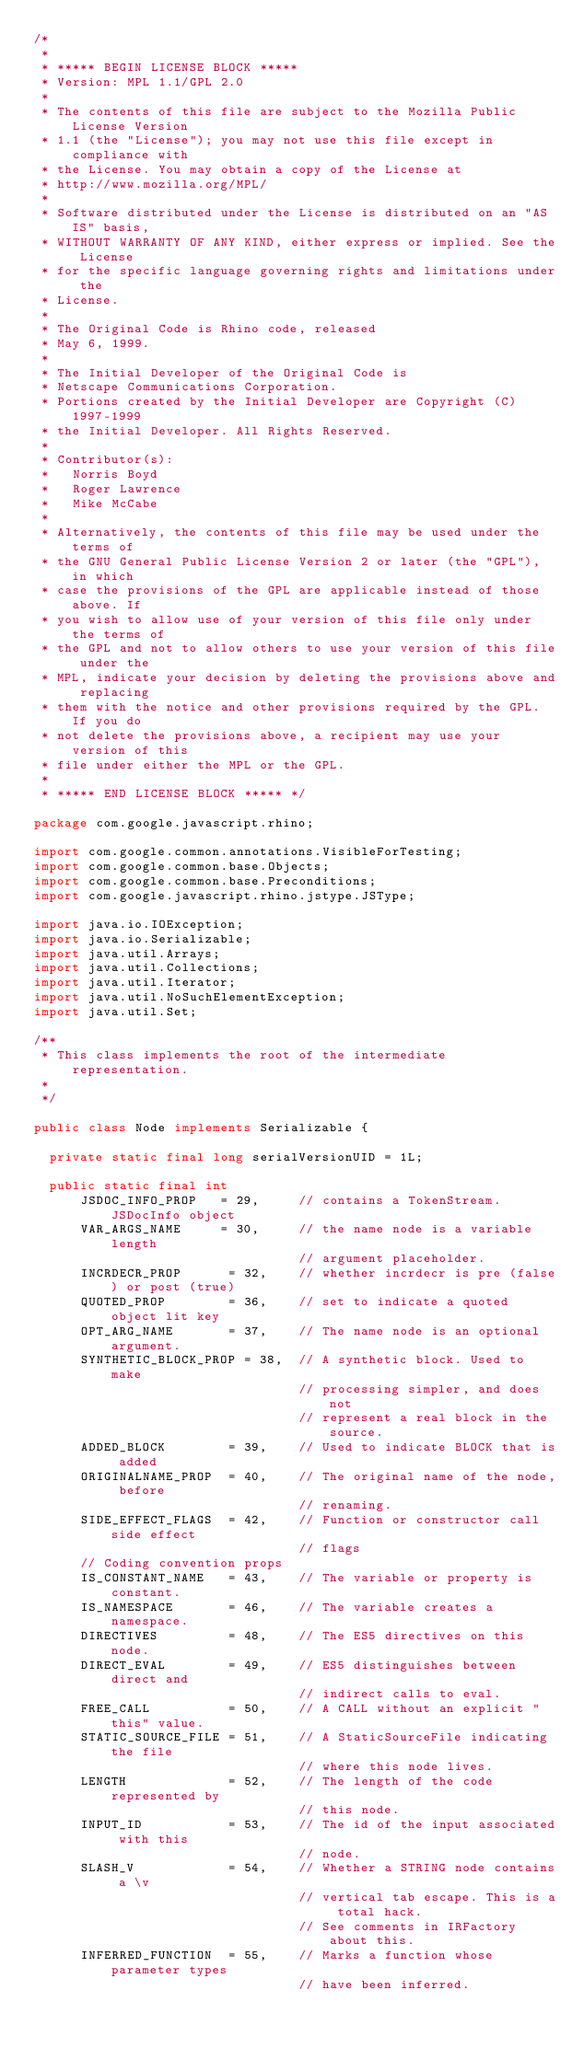<code> <loc_0><loc_0><loc_500><loc_500><_Java_>/*
 *
 * ***** BEGIN LICENSE BLOCK *****
 * Version: MPL 1.1/GPL 2.0
 *
 * The contents of this file are subject to the Mozilla Public License Version
 * 1.1 (the "License"); you may not use this file except in compliance with
 * the License. You may obtain a copy of the License at
 * http://www.mozilla.org/MPL/
 *
 * Software distributed under the License is distributed on an "AS IS" basis,
 * WITHOUT WARRANTY OF ANY KIND, either express or implied. See the License
 * for the specific language governing rights and limitations under the
 * License.
 *
 * The Original Code is Rhino code, released
 * May 6, 1999.
 *
 * The Initial Developer of the Original Code is
 * Netscape Communications Corporation.
 * Portions created by the Initial Developer are Copyright (C) 1997-1999
 * the Initial Developer. All Rights Reserved.
 *
 * Contributor(s):
 *   Norris Boyd
 *   Roger Lawrence
 *   Mike McCabe
 *
 * Alternatively, the contents of this file may be used under the terms of
 * the GNU General Public License Version 2 or later (the "GPL"), in which
 * case the provisions of the GPL are applicable instead of those above. If
 * you wish to allow use of your version of this file only under the terms of
 * the GPL and not to allow others to use your version of this file under the
 * MPL, indicate your decision by deleting the provisions above and replacing
 * them with the notice and other provisions required by the GPL. If you do
 * not delete the provisions above, a recipient may use your version of this
 * file under either the MPL or the GPL.
 *
 * ***** END LICENSE BLOCK ***** */

package com.google.javascript.rhino;

import com.google.common.annotations.VisibleForTesting;
import com.google.common.base.Objects;
import com.google.common.base.Preconditions;
import com.google.javascript.rhino.jstype.JSType;

import java.io.IOException;
import java.io.Serializable;
import java.util.Arrays;
import java.util.Collections;
import java.util.Iterator;
import java.util.NoSuchElementException;
import java.util.Set;

/**
 * This class implements the root of the intermediate representation.
 *
 */

public class Node implements Serializable {

  private static final long serialVersionUID = 1L;

  public static final int
      JSDOC_INFO_PROP   = 29,     // contains a TokenStream.JSDocInfo object
      VAR_ARGS_NAME     = 30,     // the name node is a variable length
                                  // argument placeholder.
      INCRDECR_PROP      = 32,    // whether incrdecr is pre (false) or post (true)
      QUOTED_PROP        = 36,    // set to indicate a quoted object lit key
      OPT_ARG_NAME       = 37,    // The name node is an optional argument.
      SYNTHETIC_BLOCK_PROP = 38,  // A synthetic block. Used to make
                                  // processing simpler, and does not
                                  // represent a real block in the source.
      ADDED_BLOCK        = 39,    // Used to indicate BLOCK that is added
      ORIGINALNAME_PROP  = 40,    // The original name of the node, before
                                  // renaming.
      SIDE_EFFECT_FLAGS  = 42,    // Function or constructor call side effect
                                  // flags
      // Coding convention props
      IS_CONSTANT_NAME   = 43,    // The variable or property is constant.
      IS_NAMESPACE       = 46,    // The variable creates a namespace.
      DIRECTIVES         = 48,    // The ES5 directives on this node.
      DIRECT_EVAL        = 49,    // ES5 distinguishes between direct and
                                  // indirect calls to eval.
      FREE_CALL          = 50,    // A CALL without an explicit "this" value.
      STATIC_SOURCE_FILE = 51,    // A StaticSourceFile indicating the file
                                  // where this node lives.
      LENGTH             = 52,    // The length of the code represented by
                                  // this node.
      INPUT_ID           = 53,    // The id of the input associated with this
                                  // node.
      SLASH_V            = 54,    // Whether a STRING node contains a \v
                                  // vertical tab escape. This is a total hack.
                                  // See comments in IRFactory about this.
      INFERRED_FUNCTION  = 55,    // Marks a function whose parameter types
                                  // have been inferred.</code> 